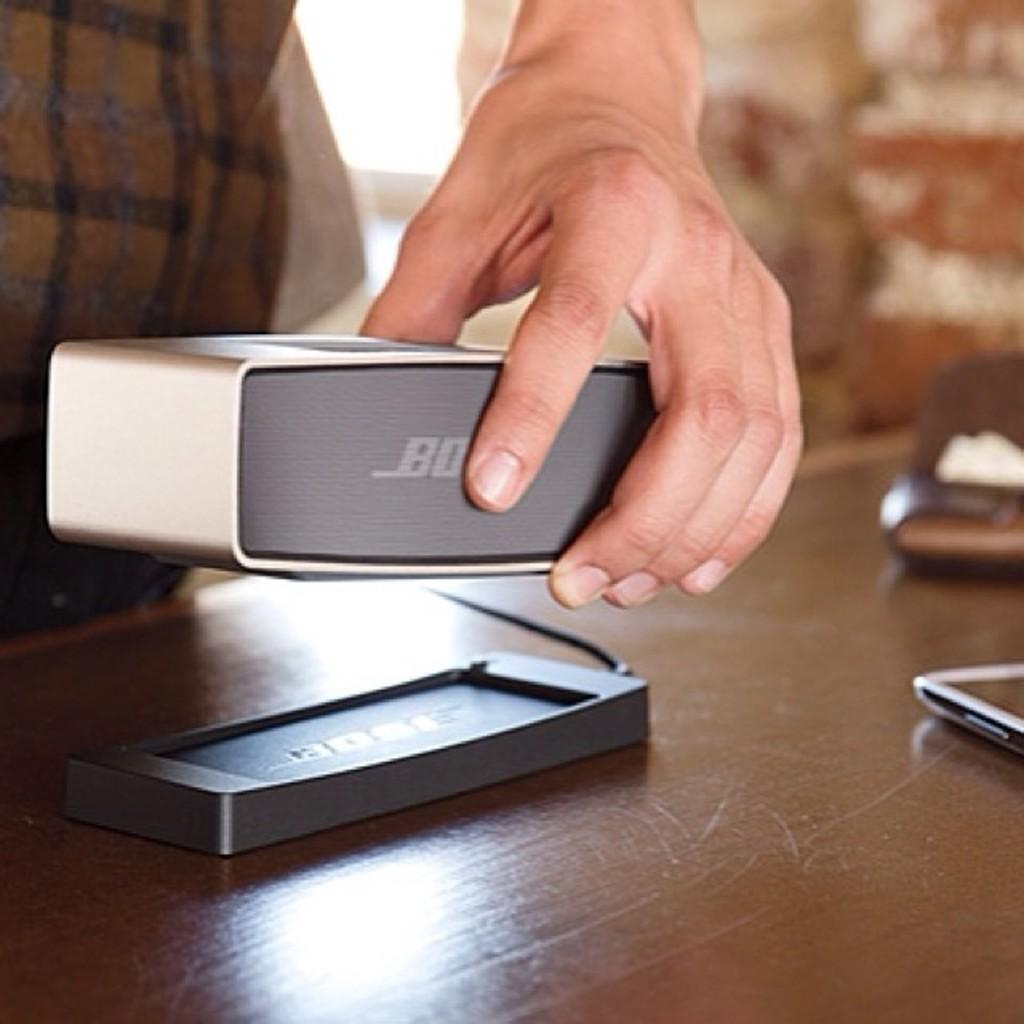What is located at the bottom of the image? There is a table at the bottom of the image. What can be seen on the table? There are electronic devices on the table. Is there anyone near the table? Yes, a person is standing behind the table. What is the person holding? The person is holding a speaker. What type of camp can be seen in the background of the image? There is no camp visible in the image; it only features a table, electronic devices, and a person holding a speaker. 